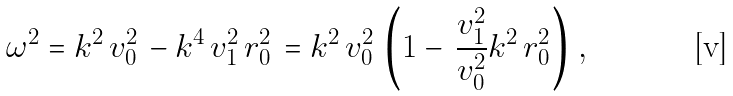<formula> <loc_0><loc_0><loc_500><loc_500>\omega ^ { 2 } = k ^ { 2 } \, v _ { 0 } ^ { 2 } \, - k ^ { 4 } \, v _ { 1 } ^ { 2 } \, r _ { 0 } ^ { 2 } \, = k ^ { 2 } \, v _ { 0 } ^ { 2 } \, \left ( 1 - \, \frac { v _ { 1 } ^ { 2 } } { v _ { 0 } ^ { 2 } } k ^ { 2 } \, r _ { 0 } ^ { 2 } \right ) \, ,</formula> 